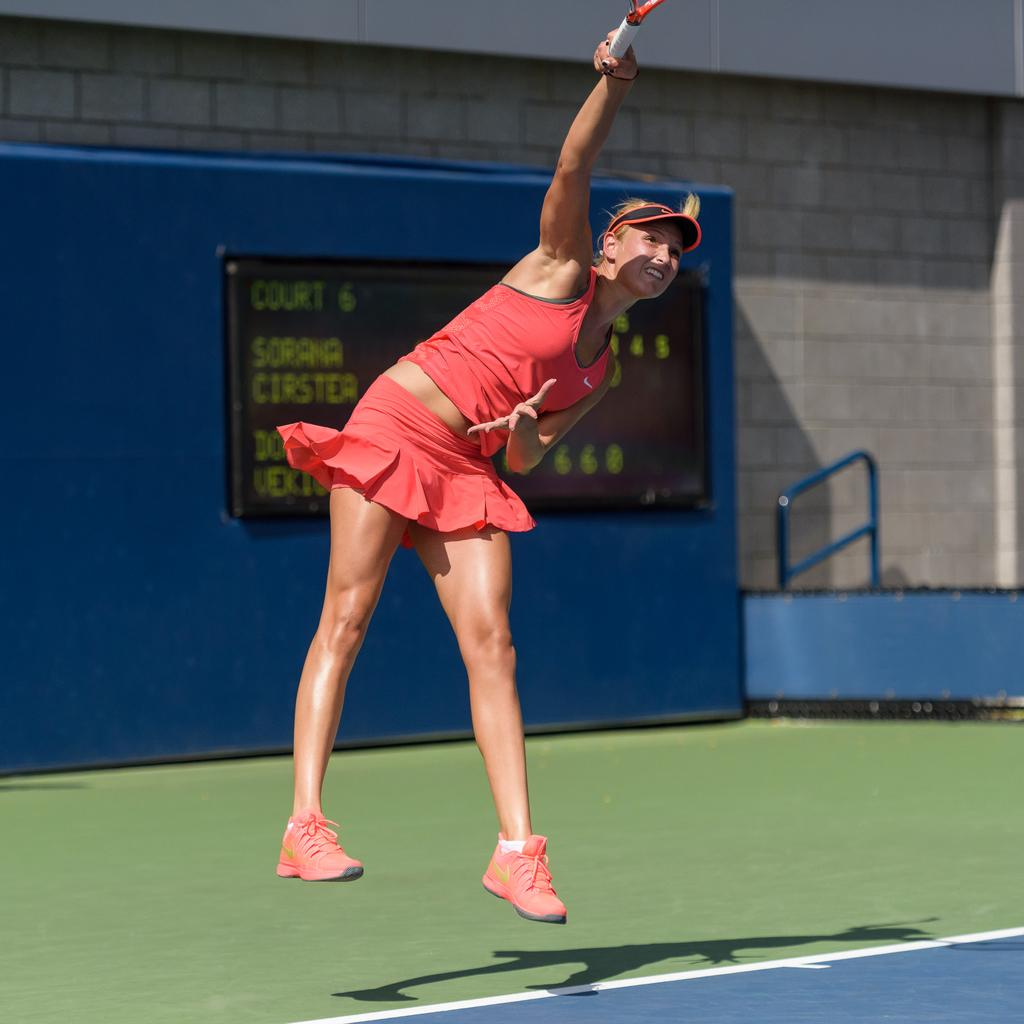Who is the main subject in the image? There is a woman in the image. What is the woman doing in the image? The woman is playing a game. What object is the woman holding in her hand? The woman is holding a bat in her hand. What type of headwear is the woman wearing? The woman is wearing a cap. What can be seen in the background of the image? There is a board and a wall in the background of the image. Can you tell me how many cables are connected to the woman's bat in the image? There are no cables connected to the woman's bat in the image. Is there a coach in the image? There is no mention of a coach in the image. 